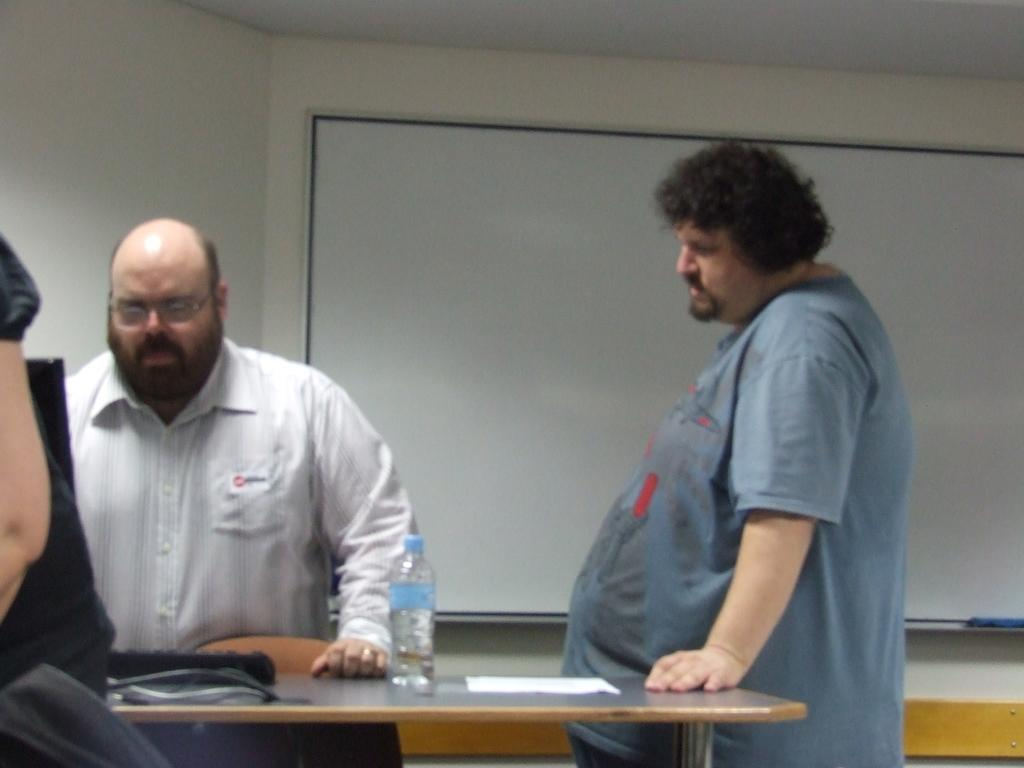Who or what is present in the image? There are people in the image. What object can be seen in the image that is typically used for holding liquids? There is a bottle in the image. What type of object is present in the image that is often used for writing or reading? There is a paper in the image. What can be seen on a table in the image that is commonly used for typing? There is a keyboard on a table in the image. What feature is present in the image that is often used for displaying notices or announcements? There is a notice board in the image. What type of tin can be seen in the image? There is no tin present in the image. What is the afterthought of the people in the image? The image does not provide information about the thoughts or intentions of the people, so it cannot be determined. 